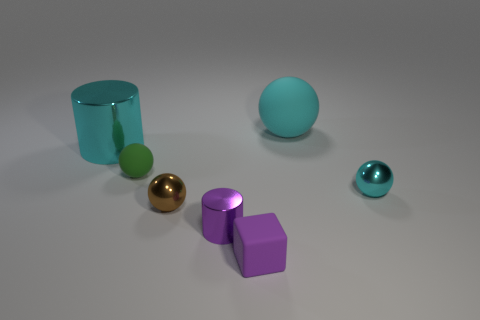Subtract all red cylinders. Subtract all yellow blocks. How many cylinders are left? 2 Add 2 big matte things. How many objects exist? 9 Subtract all blocks. How many objects are left? 6 Add 2 small metallic balls. How many small metallic balls exist? 4 Subtract 1 cyan cylinders. How many objects are left? 6 Subtract all small cyan balls. Subtract all small cyan objects. How many objects are left? 5 Add 3 spheres. How many spheres are left? 7 